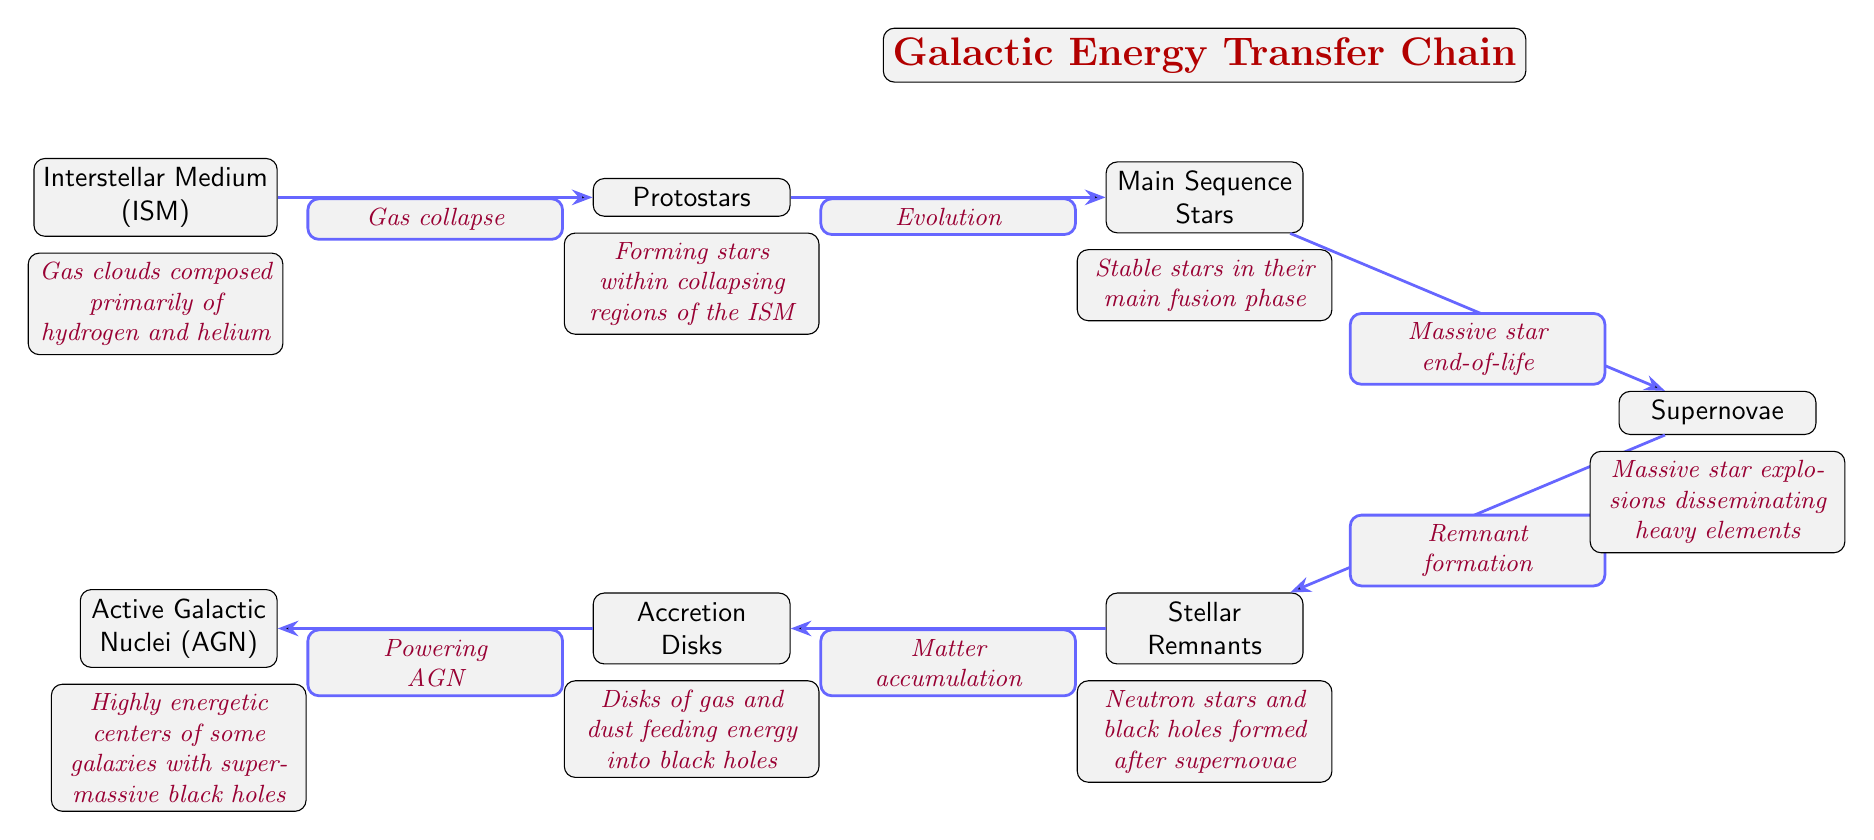What is the first node in the diagram? The diagram starts with the Interstellar Medium (ISM), which is the initial layer representing gas clouds.
Answer: Interstellar Medium (ISM) How many nodes are there in total? The diagram includes a total of 7 nodes: ISM, Protostars, Main Sequence Stars, Supernovae, Stellar Remnants, Accretion Disks, and Active Galactic Nuclei (AGN).
Answer: 7 What is the role of supernovae in this energy transfer chain? Supernovae are positioned after Main Sequence Stars and lead to the formation of Stellar Remnants, indicating they disseminate heavy elements and influence the next phase of the energy transfer.
Answer: Heavy elements dissemination Which nodes are connected by the "Matter accumulation" edge? The "Matter accumulation" edge connects Stellar Remnants to Accretion Disks, illustrating the accumulation of matter once the remnants are formed.
Answer: Stellar Remnants and Accretion Disks What follows after the Protostars in the energy transfer chain? The next node after Protostars is Main Sequence Stars, indicating that they evolve further into stable stars.
Answer: Main Sequence Stars How do Accretion Disks contribute to the energy transfer process? Accretion Disks are linked to Active Galactic Nuclei (AGN) through the "Powering AGN" edge, suggesting they provide energy to the highly energetic centers of some galaxies where supermassive black holes reside.
Answer: Powering AGN Which node represents a stable phase of stellar life? The node for Main Sequence Stars represents a stable phase, as it signifies stars undergoing their main fusion process.
Answer: Main Sequence Stars What is the descriptive function of the Interstellar Medium (ISM) in the diagram? The ISM serves as the basic building block, consisting of gas clouds primarily made of hydrogen and helium, initiating the energy transfer process.
Answer: Gas clouds composed primarily of hydrogen and helium 